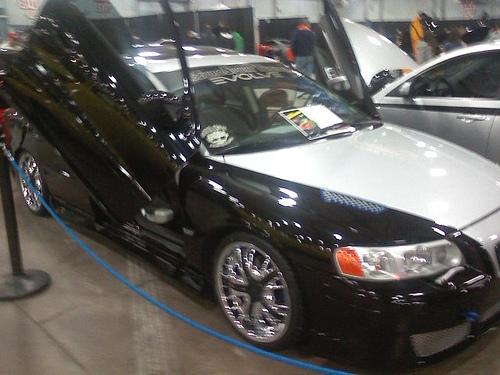<image>
Can you confirm if the wheel is next to the car? No. The wheel is not positioned next to the car. They are located in different areas of the scene. 